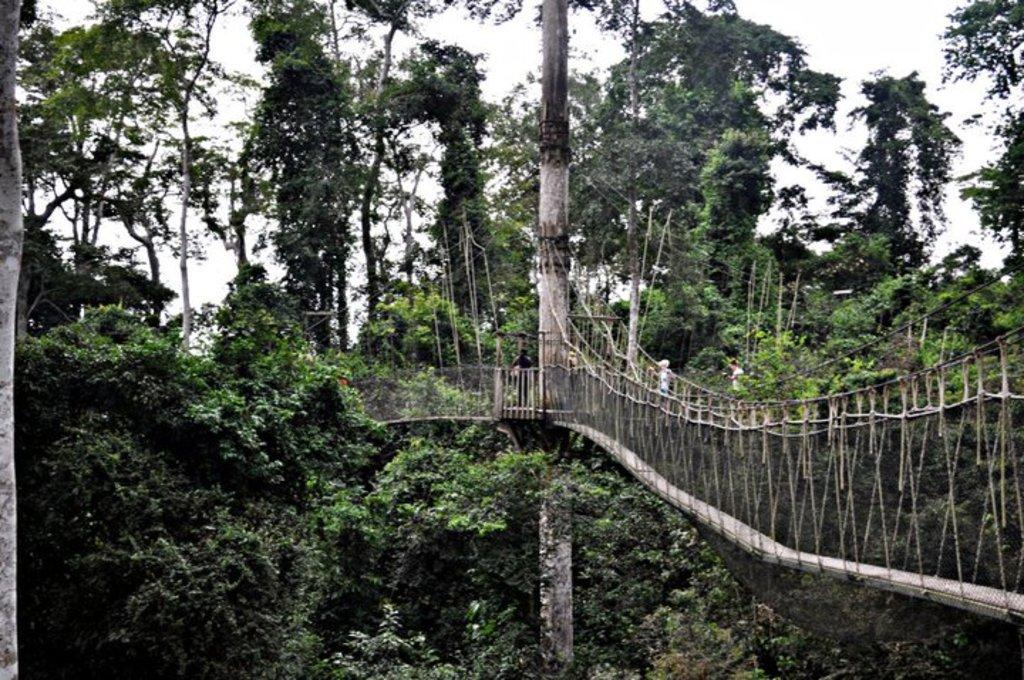What structure is the main subject of the image? There is a bridge in the image. What can be seen in the background of the image? There are trees in the background of the image. What is the color of the trees? The trees are green in color. What else is visible in the image? The sky is visible in the image. What is the color of the sky? The sky is white in color. Can you see a cat playing a guitar under the bridge in the image? No, there is no cat or guitar present in the image. The image features a bridge, trees, and a white sky. 